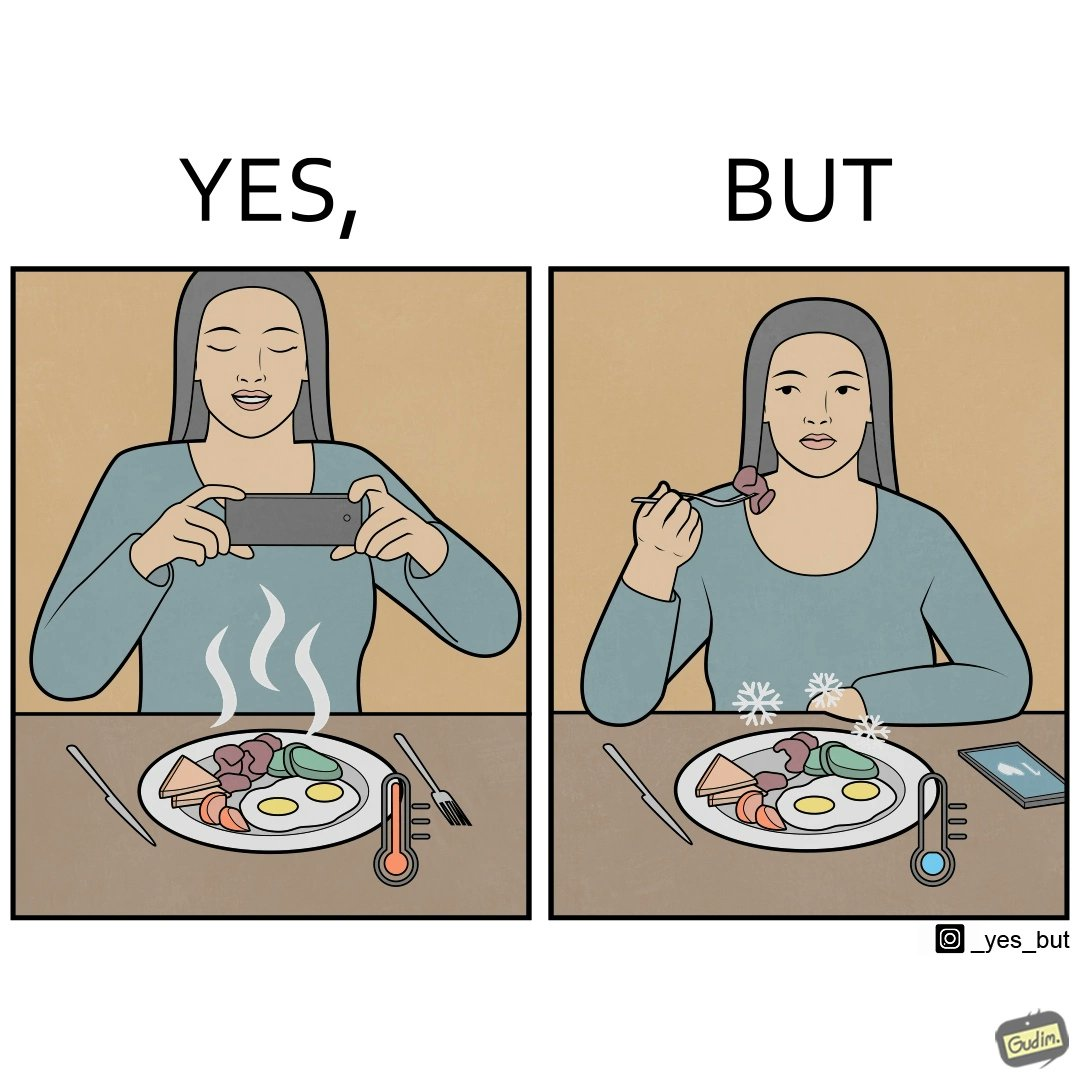Why is this image considered satirical? The images are funny since they show how a woman chooses to spend time clicking pictures of her food and by the time she is done, the food is already cold and not as appetizing as it was 